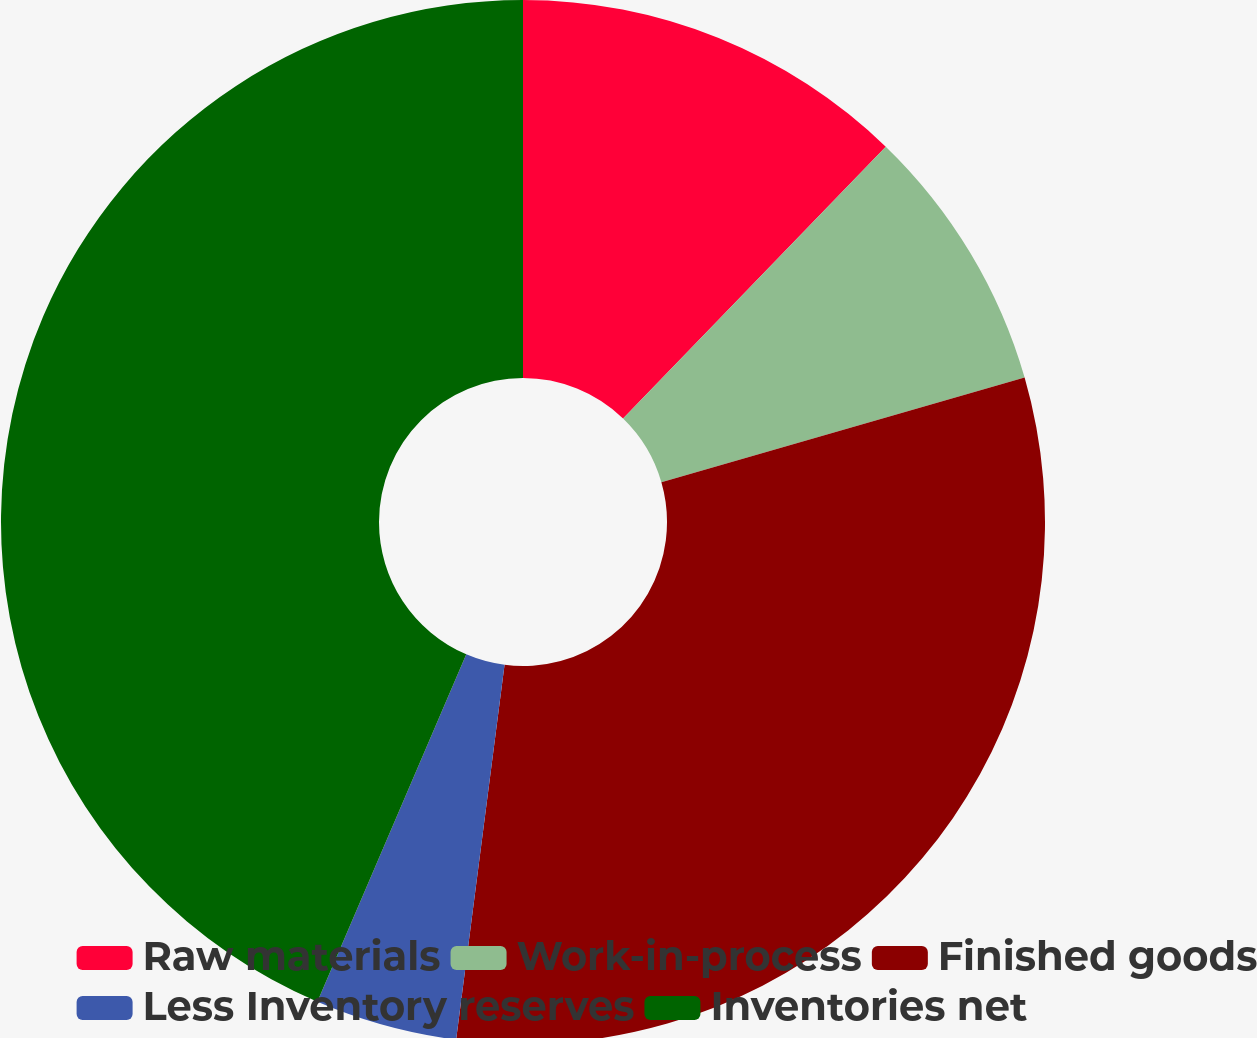<chart> <loc_0><loc_0><loc_500><loc_500><pie_chart><fcel>Raw materials<fcel>Work-in-process<fcel>Finished goods<fcel>Less Inventory reserves<fcel>Inventories net<nl><fcel>12.23%<fcel>8.31%<fcel>31.51%<fcel>4.4%<fcel>43.56%<nl></chart> 